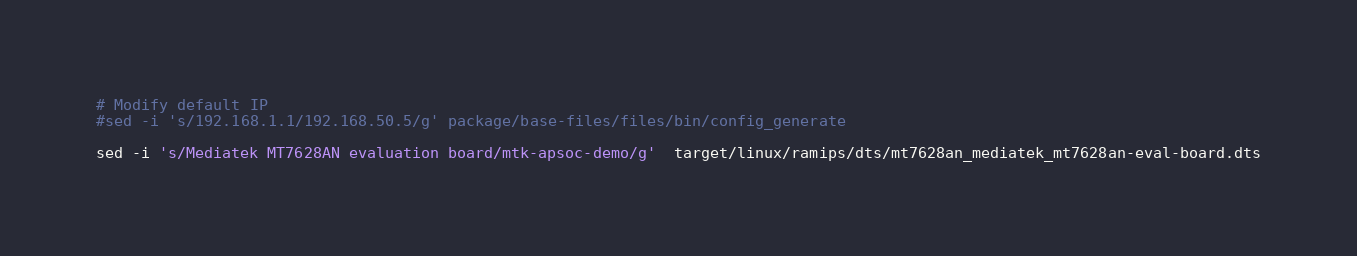<code> <loc_0><loc_0><loc_500><loc_500><_Bash_># Modify default IP
#sed -i 's/192.168.1.1/192.168.50.5/g' package/base-files/files/bin/config_generate

sed -i 's/Mediatek MT7628AN evaluation board/mtk-apsoc-demo/g'  target/linux/ramips/dts/mt7628an_mediatek_mt7628an-eval-board.dts
</code> 